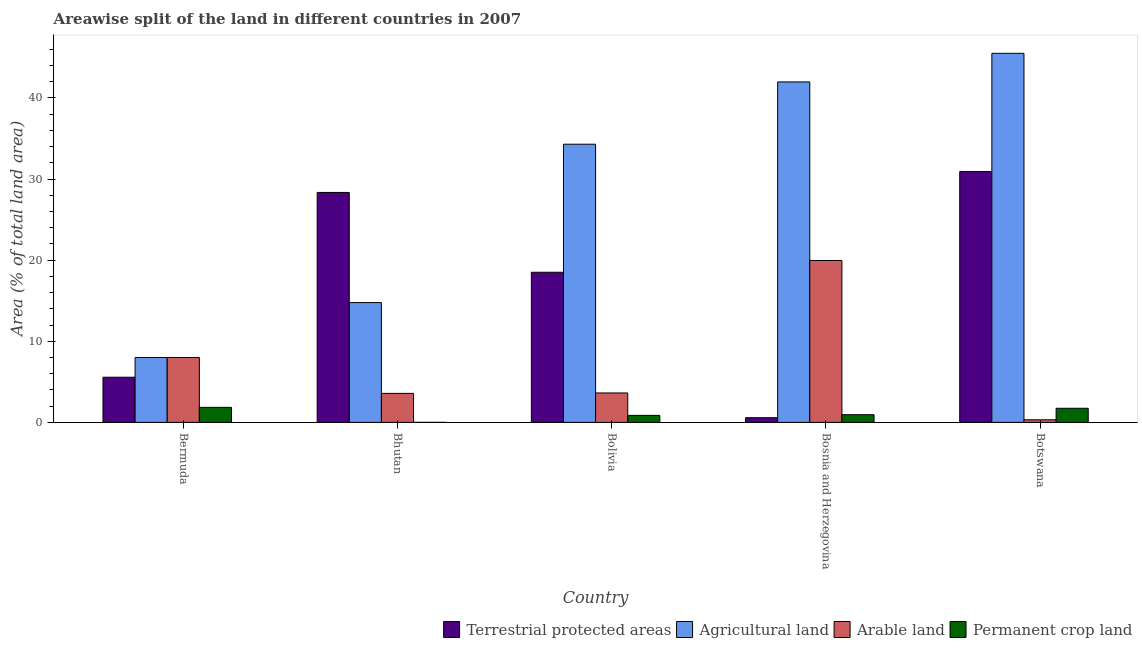Are the number of bars on each tick of the X-axis equal?
Your response must be concise. Yes. How many bars are there on the 4th tick from the right?
Give a very brief answer. 4. What is the label of the 5th group of bars from the left?
Provide a short and direct response. Botswana. In how many cases, is the number of bars for a given country not equal to the number of legend labels?
Your answer should be compact. 0. What is the percentage of area under arable land in Botswana?
Your answer should be very brief. 0.32. Across all countries, what is the maximum percentage of land under terrestrial protection?
Ensure brevity in your answer.  30.93. Across all countries, what is the minimum percentage of area under arable land?
Provide a succinct answer. 0.32. In which country was the percentage of area under agricultural land maximum?
Your answer should be very brief. Botswana. In which country was the percentage of area under permanent crop land minimum?
Offer a terse response. Bhutan. What is the total percentage of area under arable land in the graph?
Keep it short and to the point. 35.49. What is the difference between the percentage of area under arable land in Bermuda and that in Bolivia?
Offer a very short reply. 4.37. What is the difference between the percentage of area under permanent crop land in Bolivia and the percentage of area under arable land in Bhutan?
Give a very brief answer. -2.71. What is the average percentage of land under terrestrial protection per country?
Provide a succinct answer. 16.79. What is the difference between the percentage of land under terrestrial protection and percentage of area under agricultural land in Bosnia and Herzegovina?
Your answer should be very brief. -41.39. In how many countries, is the percentage of land under terrestrial protection greater than 42 %?
Your response must be concise. 0. What is the ratio of the percentage of area under permanent crop land in Bolivia to that in Botswana?
Ensure brevity in your answer.  0.5. Is the difference between the percentage of area under permanent crop land in Bosnia and Herzegovina and Botswana greater than the difference between the percentage of area under agricultural land in Bosnia and Herzegovina and Botswana?
Offer a very short reply. Yes. What is the difference between the highest and the second highest percentage of area under permanent crop land?
Offer a terse response. 0.12. What is the difference between the highest and the lowest percentage of land under terrestrial protection?
Offer a terse response. 30.35. Is the sum of the percentage of area under permanent crop land in Bermuda and Bhutan greater than the maximum percentage of land under terrestrial protection across all countries?
Provide a succinct answer. No. Is it the case that in every country, the sum of the percentage of area under permanent crop land and percentage of area under agricultural land is greater than the sum of percentage of land under terrestrial protection and percentage of area under arable land?
Ensure brevity in your answer.  No. What does the 2nd bar from the left in Bhutan represents?
Give a very brief answer. Agricultural land. What does the 4th bar from the right in Bolivia represents?
Your answer should be very brief. Terrestrial protected areas. Are all the bars in the graph horizontal?
Provide a succinct answer. No. What is the difference between two consecutive major ticks on the Y-axis?
Your response must be concise. 10. Are the values on the major ticks of Y-axis written in scientific E-notation?
Your response must be concise. No. How are the legend labels stacked?
Make the answer very short. Horizontal. What is the title of the graph?
Ensure brevity in your answer.  Areawise split of the land in different countries in 2007. Does "Taxes on revenue" appear as one of the legend labels in the graph?
Keep it short and to the point. No. What is the label or title of the X-axis?
Keep it short and to the point. Country. What is the label or title of the Y-axis?
Offer a very short reply. Area (% of total land area). What is the Area (% of total land area) in Terrestrial protected areas in Bermuda?
Offer a terse response. 5.57. What is the Area (% of total land area) of Arable land in Bermuda?
Offer a terse response. 8. What is the Area (% of total land area) of Permanent crop land in Bermuda?
Offer a terse response. 1.86. What is the Area (% of total land area) of Terrestrial protected areas in Bhutan?
Provide a succinct answer. 28.35. What is the Area (% of total land area) of Agricultural land in Bhutan?
Give a very brief answer. 14.77. What is the Area (% of total land area) in Arable land in Bhutan?
Make the answer very short. 3.58. What is the Area (% of total land area) in Permanent crop land in Bhutan?
Offer a very short reply. 0. What is the Area (% of total land area) in Terrestrial protected areas in Bolivia?
Your response must be concise. 18.51. What is the Area (% of total land area) in Agricultural land in Bolivia?
Offer a very short reply. 34.29. What is the Area (% of total land area) of Arable land in Bolivia?
Provide a short and direct response. 3.63. What is the Area (% of total land area) in Permanent crop land in Bolivia?
Provide a succinct answer. 0.87. What is the Area (% of total land area) in Terrestrial protected areas in Bosnia and Herzegovina?
Offer a very short reply. 0.58. What is the Area (% of total land area) of Agricultural land in Bosnia and Herzegovina?
Offer a very short reply. 41.97. What is the Area (% of total land area) of Arable land in Bosnia and Herzegovina?
Provide a short and direct response. 19.96. What is the Area (% of total land area) in Permanent crop land in Bosnia and Herzegovina?
Ensure brevity in your answer.  0.95. What is the Area (% of total land area) in Terrestrial protected areas in Botswana?
Give a very brief answer. 30.93. What is the Area (% of total land area) of Agricultural land in Botswana?
Ensure brevity in your answer.  45.5. What is the Area (% of total land area) of Arable land in Botswana?
Provide a short and direct response. 0.32. What is the Area (% of total land area) of Permanent crop land in Botswana?
Offer a very short reply. 1.74. Across all countries, what is the maximum Area (% of total land area) of Terrestrial protected areas?
Give a very brief answer. 30.93. Across all countries, what is the maximum Area (% of total land area) in Agricultural land?
Your response must be concise. 45.5. Across all countries, what is the maximum Area (% of total land area) in Arable land?
Ensure brevity in your answer.  19.96. Across all countries, what is the maximum Area (% of total land area) in Permanent crop land?
Your answer should be very brief. 1.86. Across all countries, what is the minimum Area (% of total land area) in Terrestrial protected areas?
Offer a very short reply. 0.58. Across all countries, what is the minimum Area (% of total land area) in Agricultural land?
Give a very brief answer. 8. Across all countries, what is the minimum Area (% of total land area) in Arable land?
Your response must be concise. 0.32. Across all countries, what is the minimum Area (% of total land area) in Permanent crop land?
Provide a short and direct response. 0. What is the total Area (% of total land area) in Terrestrial protected areas in the graph?
Provide a short and direct response. 83.94. What is the total Area (% of total land area) in Agricultural land in the graph?
Ensure brevity in your answer.  144.53. What is the total Area (% of total land area) of Arable land in the graph?
Keep it short and to the point. 35.49. What is the total Area (% of total land area) in Permanent crop land in the graph?
Your response must be concise. 5.42. What is the difference between the Area (% of total land area) of Terrestrial protected areas in Bermuda and that in Bhutan?
Your answer should be very brief. -22.78. What is the difference between the Area (% of total land area) in Agricultural land in Bermuda and that in Bhutan?
Keep it short and to the point. -6.77. What is the difference between the Area (% of total land area) in Arable land in Bermuda and that in Bhutan?
Give a very brief answer. 4.42. What is the difference between the Area (% of total land area) of Permanent crop land in Bermuda and that in Bhutan?
Offer a terse response. 1.85. What is the difference between the Area (% of total land area) in Terrestrial protected areas in Bermuda and that in Bolivia?
Your answer should be very brief. -12.94. What is the difference between the Area (% of total land area) of Agricultural land in Bermuda and that in Bolivia?
Your response must be concise. -26.29. What is the difference between the Area (% of total land area) of Arable land in Bermuda and that in Bolivia?
Ensure brevity in your answer.  4.37. What is the difference between the Area (% of total land area) in Terrestrial protected areas in Bermuda and that in Bosnia and Herzegovina?
Provide a short and direct response. 4.99. What is the difference between the Area (% of total land area) in Agricultural land in Bermuda and that in Bosnia and Herzegovina?
Keep it short and to the point. -33.97. What is the difference between the Area (% of total land area) in Arable land in Bermuda and that in Bosnia and Herzegovina?
Give a very brief answer. -11.96. What is the difference between the Area (% of total land area) of Permanent crop land in Bermuda and that in Bosnia and Herzegovina?
Your answer should be compact. 0.91. What is the difference between the Area (% of total land area) in Terrestrial protected areas in Bermuda and that in Botswana?
Provide a succinct answer. -25.36. What is the difference between the Area (% of total land area) of Agricultural land in Bermuda and that in Botswana?
Ensure brevity in your answer.  -37.5. What is the difference between the Area (% of total land area) of Arable land in Bermuda and that in Botswana?
Your response must be concise. 7.68. What is the difference between the Area (% of total land area) in Permanent crop land in Bermuda and that in Botswana?
Ensure brevity in your answer.  0.12. What is the difference between the Area (% of total land area) in Terrestrial protected areas in Bhutan and that in Bolivia?
Your answer should be compact. 9.84. What is the difference between the Area (% of total land area) of Agricultural land in Bhutan and that in Bolivia?
Offer a terse response. -19.52. What is the difference between the Area (% of total land area) in Arable land in Bhutan and that in Bolivia?
Offer a very short reply. -0.05. What is the difference between the Area (% of total land area) in Permanent crop land in Bhutan and that in Bolivia?
Offer a terse response. -0.86. What is the difference between the Area (% of total land area) in Terrestrial protected areas in Bhutan and that in Bosnia and Herzegovina?
Offer a very short reply. 27.77. What is the difference between the Area (% of total land area) of Agricultural land in Bhutan and that in Bosnia and Herzegovina?
Provide a short and direct response. -27.2. What is the difference between the Area (% of total land area) of Arable land in Bhutan and that in Bosnia and Herzegovina?
Your answer should be very brief. -16.39. What is the difference between the Area (% of total land area) in Permanent crop land in Bhutan and that in Bosnia and Herzegovina?
Provide a succinct answer. -0.95. What is the difference between the Area (% of total land area) of Terrestrial protected areas in Bhutan and that in Botswana?
Ensure brevity in your answer.  -2.59. What is the difference between the Area (% of total land area) in Agricultural land in Bhutan and that in Botswana?
Your response must be concise. -30.73. What is the difference between the Area (% of total land area) in Arable land in Bhutan and that in Botswana?
Offer a very short reply. 3.25. What is the difference between the Area (% of total land area) in Permanent crop land in Bhutan and that in Botswana?
Give a very brief answer. -1.74. What is the difference between the Area (% of total land area) of Terrestrial protected areas in Bolivia and that in Bosnia and Herzegovina?
Offer a terse response. 17.93. What is the difference between the Area (% of total land area) in Agricultural land in Bolivia and that in Bosnia and Herzegovina?
Make the answer very short. -7.68. What is the difference between the Area (% of total land area) of Arable land in Bolivia and that in Bosnia and Herzegovina?
Offer a very short reply. -16.33. What is the difference between the Area (% of total land area) in Permanent crop land in Bolivia and that in Bosnia and Herzegovina?
Offer a terse response. -0.08. What is the difference between the Area (% of total land area) of Terrestrial protected areas in Bolivia and that in Botswana?
Your response must be concise. -12.43. What is the difference between the Area (% of total land area) in Agricultural land in Bolivia and that in Botswana?
Give a very brief answer. -11.2. What is the difference between the Area (% of total land area) in Arable land in Bolivia and that in Botswana?
Ensure brevity in your answer.  3.31. What is the difference between the Area (% of total land area) of Permanent crop land in Bolivia and that in Botswana?
Your response must be concise. -0.87. What is the difference between the Area (% of total land area) of Terrestrial protected areas in Bosnia and Herzegovina and that in Botswana?
Make the answer very short. -30.35. What is the difference between the Area (% of total land area) of Agricultural land in Bosnia and Herzegovina and that in Botswana?
Your response must be concise. -3.52. What is the difference between the Area (% of total land area) of Arable land in Bosnia and Herzegovina and that in Botswana?
Give a very brief answer. 19.64. What is the difference between the Area (% of total land area) in Permanent crop land in Bosnia and Herzegovina and that in Botswana?
Your answer should be very brief. -0.79. What is the difference between the Area (% of total land area) in Terrestrial protected areas in Bermuda and the Area (% of total land area) in Agricultural land in Bhutan?
Offer a terse response. -9.2. What is the difference between the Area (% of total land area) in Terrestrial protected areas in Bermuda and the Area (% of total land area) in Arable land in Bhutan?
Provide a short and direct response. 1.99. What is the difference between the Area (% of total land area) of Terrestrial protected areas in Bermuda and the Area (% of total land area) of Permanent crop land in Bhutan?
Your answer should be compact. 5.57. What is the difference between the Area (% of total land area) of Agricultural land in Bermuda and the Area (% of total land area) of Arable land in Bhutan?
Provide a succinct answer. 4.42. What is the difference between the Area (% of total land area) in Agricultural land in Bermuda and the Area (% of total land area) in Permanent crop land in Bhutan?
Give a very brief answer. 8. What is the difference between the Area (% of total land area) in Arable land in Bermuda and the Area (% of total land area) in Permanent crop land in Bhutan?
Your answer should be very brief. 8. What is the difference between the Area (% of total land area) of Terrestrial protected areas in Bermuda and the Area (% of total land area) of Agricultural land in Bolivia?
Your answer should be compact. -28.72. What is the difference between the Area (% of total land area) of Terrestrial protected areas in Bermuda and the Area (% of total land area) of Arable land in Bolivia?
Your answer should be very brief. 1.94. What is the difference between the Area (% of total land area) in Terrestrial protected areas in Bermuda and the Area (% of total land area) in Permanent crop land in Bolivia?
Give a very brief answer. 4.7. What is the difference between the Area (% of total land area) in Agricultural land in Bermuda and the Area (% of total land area) in Arable land in Bolivia?
Your answer should be very brief. 4.37. What is the difference between the Area (% of total land area) of Agricultural land in Bermuda and the Area (% of total land area) of Permanent crop land in Bolivia?
Your answer should be very brief. 7.13. What is the difference between the Area (% of total land area) of Arable land in Bermuda and the Area (% of total land area) of Permanent crop land in Bolivia?
Your answer should be very brief. 7.13. What is the difference between the Area (% of total land area) in Terrestrial protected areas in Bermuda and the Area (% of total land area) in Agricultural land in Bosnia and Herzegovina?
Make the answer very short. -36.4. What is the difference between the Area (% of total land area) of Terrestrial protected areas in Bermuda and the Area (% of total land area) of Arable land in Bosnia and Herzegovina?
Your answer should be compact. -14.39. What is the difference between the Area (% of total land area) in Terrestrial protected areas in Bermuda and the Area (% of total land area) in Permanent crop land in Bosnia and Herzegovina?
Ensure brevity in your answer.  4.62. What is the difference between the Area (% of total land area) of Agricultural land in Bermuda and the Area (% of total land area) of Arable land in Bosnia and Herzegovina?
Your answer should be very brief. -11.96. What is the difference between the Area (% of total land area) of Agricultural land in Bermuda and the Area (% of total land area) of Permanent crop land in Bosnia and Herzegovina?
Make the answer very short. 7.05. What is the difference between the Area (% of total land area) in Arable land in Bermuda and the Area (% of total land area) in Permanent crop land in Bosnia and Herzegovina?
Give a very brief answer. 7.05. What is the difference between the Area (% of total land area) in Terrestrial protected areas in Bermuda and the Area (% of total land area) in Agricultural land in Botswana?
Offer a very short reply. -39.93. What is the difference between the Area (% of total land area) of Terrestrial protected areas in Bermuda and the Area (% of total land area) of Arable land in Botswana?
Ensure brevity in your answer.  5.25. What is the difference between the Area (% of total land area) in Terrestrial protected areas in Bermuda and the Area (% of total land area) in Permanent crop land in Botswana?
Provide a succinct answer. 3.83. What is the difference between the Area (% of total land area) of Agricultural land in Bermuda and the Area (% of total land area) of Arable land in Botswana?
Ensure brevity in your answer.  7.68. What is the difference between the Area (% of total land area) of Agricultural land in Bermuda and the Area (% of total land area) of Permanent crop land in Botswana?
Offer a very short reply. 6.26. What is the difference between the Area (% of total land area) in Arable land in Bermuda and the Area (% of total land area) in Permanent crop land in Botswana?
Make the answer very short. 6.26. What is the difference between the Area (% of total land area) in Terrestrial protected areas in Bhutan and the Area (% of total land area) in Agricultural land in Bolivia?
Your answer should be very brief. -5.95. What is the difference between the Area (% of total land area) in Terrestrial protected areas in Bhutan and the Area (% of total land area) in Arable land in Bolivia?
Offer a very short reply. 24.72. What is the difference between the Area (% of total land area) of Terrestrial protected areas in Bhutan and the Area (% of total land area) of Permanent crop land in Bolivia?
Your response must be concise. 27.48. What is the difference between the Area (% of total land area) in Agricultural land in Bhutan and the Area (% of total land area) in Arable land in Bolivia?
Ensure brevity in your answer.  11.14. What is the difference between the Area (% of total land area) of Agricultural land in Bhutan and the Area (% of total land area) of Permanent crop land in Bolivia?
Provide a succinct answer. 13.9. What is the difference between the Area (% of total land area) of Arable land in Bhutan and the Area (% of total land area) of Permanent crop land in Bolivia?
Offer a very short reply. 2.71. What is the difference between the Area (% of total land area) in Terrestrial protected areas in Bhutan and the Area (% of total land area) in Agricultural land in Bosnia and Herzegovina?
Provide a succinct answer. -13.63. What is the difference between the Area (% of total land area) in Terrestrial protected areas in Bhutan and the Area (% of total land area) in Arable land in Bosnia and Herzegovina?
Your answer should be compact. 8.39. What is the difference between the Area (% of total land area) in Terrestrial protected areas in Bhutan and the Area (% of total land area) in Permanent crop land in Bosnia and Herzegovina?
Ensure brevity in your answer.  27.4. What is the difference between the Area (% of total land area) in Agricultural land in Bhutan and the Area (% of total land area) in Arable land in Bosnia and Herzegovina?
Provide a succinct answer. -5.19. What is the difference between the Area (% of total land area) in Agricultural land in Bhutan and the Area (% of total land area) in Permanent crop land in Bosnia and Herzegovina?
Offer a very short reply. 13.82. What is the difference between the Area (% of total land area) in Arable land in Bhutan and the Area (% of total land area) in Permanent crop land in Bosnia and Herzegovina?
Offer a terse response. 2.63. What is the difference between the Area (% of total land area) of Terrestrial protected areas in Bhutan and the Area (% of total land area) of Agricultural land in Botswana?
Provide a succinct answer. -17.15. What is the difference between the Area (% of total land area) in Terrestrial protected areas in Bhutan and the Area (% of total land area) in Arable land in Botswana?
Provide a succinct answer. 28.03. What is the difference between the Area (% of total land area) in Terrestrial protected areas in Bhutan and the Area (% of total land area) in Permanent crop land in Botswana?
Keep it short and to the point. 26.61. What is the difference between the Area (% of total land area) in Agricultural land in Bhutan and the Area (% of total land area) in Arable land in Botswana?
Keep it short and to the point. 14.45. What is the difference between the Area (% of total land area) of Agricultural land in Bhutan and the Area (% of total land area) of Permanent crop land in Botswana?
Offer a terse response. 13.03. What is the difference between the Area (% of total land area) in Arable land in Bhutan and the Area (% of total land area) in Permanent crop land in Botswana?
Your response must be concise. 1.84. What is the difference between the Area (% of total land area) of Terrestrial protected areas in Bolivia and the Area (% of total land area) of Agricultural land in Bosnia and Herzegovina?
Your response must be concise. -23.47. What is the difference between the Area (% of total land area) of Terrestrial protected areas in Bolivia and the Area (% of total land area) of Arable land in Bosnia and Herzegovina?
Offer a terse response. -1.45. What is the difference between the Area (% of total land area) in Terrestrial protected areas in Bolivia and the Area (% of total land area) in Permanent crop land in Bosnia and Herzegovina?
Give a very brief answer. 17.56. What is the difference between the Area (% of total land area) of Agricultural land in Bolivia and the Area (% of total land area) of Arable land in Bosnia and Herzegovina?
Offer a very short reply. 14.33. What is the difference between the Area (% of total land area) in Agricultural land in Bolivia and the Area (% of total land area) in Permanent crop land in Bosnia and Herzegovina?
Your response must be concise. 33.34. What is the difference between the Area (% of total land area) of Arable land in Bolivia and the Area (% of total land area) of Permanent crop land in Bosnia and Herzegovina?
Give a very brief answer. 2.68. What is the difference between the Area (% of total land area) in Terrestrial protected areas in Bolivia and the Area (% of total land area) in Agricultural land in Botswana?
Give a very brief answer. -26.99. What is the difference between the Area (% of total land area) in Terrestrial protected areas in Bolivia and the Area (% of total land area) in Arable land in Botswana?
Offer a terse response. 18.19. What is the difference between the Area (% of total land area) of Terrestrial protected areas in Bolivia and the Area (% of total land area) of Permanent crop land in Botswana?
Keep it short and to the point. 16.77. What is the difference between the Area (% of total land area) of Agricultural land in Bolivia and the Area (% of total land area) of Arable land in Botswana?
Keep it short and to the point. 33.97. What is the difference between the Area (% of total land area) of Agricultural land in Bolivia and the Area (% of total land area) of Permanent crop land in Botswana?
Provide a succinct answer. 32.55. What is the difference between the Area (% of total land area) of Arable land in Bolivia and the Area (% of total land area) of Permanent crop land in Botswana?
Your answer should be very brief. 1.89. What is the difference between the Area (% of total land area) in Terrestrial protected areas in Bosnia and Herzegovina and the Area (% of total land area) in Agricultural land in Botswana?
Give a very brief answer. -44.92. What is the difference between the Area (% of total land area) in Terrestrial protected areas in Bosnia and Herzegovina and the Area (% of total land area) in Arable land in Botswana?
Offer a terse response. 0.26. What is the difference between the Area (% of total land area) in Terrestrial protected areas in Bosnia and Herzegovina and the Area (% of total land area) in Permanent crop land in Botswana?
Your answer should be very brief. -1.16. What is the difference between the Area (% of total land area) in Agricultural land in Bosnia and Herzegovina and the Area (% of total land area) in Arable land in Botswana?
Offer a very short reply. 41.65. What is the difference between the Area (% of total land area) of Agricultural land in Bosnia and Herzegovina and the Area (% of total land area) of Permanent crop land in Botswana?
Make the answer very short. 40.23. What is the difference between the Area (% of total land area) in Arable land in Bosnia and Herzegovina and the Area (% of total land area) in Permanent crop land in Botswana?
Your response must be concise. 18.22. What is the average Area (% of total land area) of Terrestrial protected areas per country?
Your answer should be compact. 16.79. What is the average Area (% of total land area) in Agricultural land per country?
Provide a short and direct response. 28.91. What is the average Area (% of total land area) of Arable land per country?
Make the answer very short. 7.1. What is the average Area (% of total land area) in Permanent crop land per country?
Provide a short and direct response. 1.08. What is the difference between the Area (% of total land area) in Terrestrial protected areas and Area (% of total land area) in Agricultural land in Bermuda?
Your answer should be compact. -2.43. What is the difference between the Area (% of total land area) of Terrestrial protected areas and Area (% of total land area) of Arable land in Bermuda?
Your response must be concise. -2.43. What is the difference between the Area (% of total land area) of Terrestrial protected areas and Area (% of total land area) of Permanent crop land in Bermuda?
Offer a terse response. 3.71. What is the difference between the Area (% of total land area) in Agricultural land and Area (% of total land area) in Arable land in Bermuda?
Provide a succinct answer. 0. What is the difference between the Area (% of total land area) of Agricultural land and Area (% of total land area) of Permanent crop land in Bermuda?
Keep it short and to the point. 6.14. What is the difference between the Area (% of total land area) of Arable land and Area (% of total land area) of Permanent crop land in Bermuda?
Make the answer very short. 6.14. What is the difference between the Area (% of total land area) in Terrestrial protected areas and Area (% of total land area) in Agricultural land in Bhutan?
Make the answer very short. 13.58. What is the difference between the Area (% of total land area) of Terrestrial protected areas and Area (% of total land area) of Arable land in Bhutan?
Provide a short and direct response. 24.77. What is the difference between the Area (% of total land area) of Terrestrial protected areas and Area (% of total land area) of Permanent crop land in Bhutan?
Your response must be concise. 28.34. What is the difference between the Area (% of total land area) of Agricultural land and Area (% of total land area) of Arable land in Bhutan?
Your response must be concise. 11.19. What is the difference between the Area (% of total land area) in Agricultural land and Area (% of total land area) in Permanent crop land in Bhutan?
Offer a terse response. 14.77. What is the difference between the Area (% of total land area) of Arable land and Area (% of total land area) of Permanent crop land in Bhutan?
Offer a terse response. 3.57. What is the difference between the Area (% of total land area) of Terrestrial protected areas and Area (% of total land area) of Agricultural land in Bolivia?
Provide a short and direct response. -15.79. What is the difference between the Area (% of total land area) of Terrestrial protected areas and Area (% of total land area) of Arable land in Bolivia?
Give a very brief answer. 14.88. What is the difference between the Area (% of total land area) in Terrestrial protected areas and Area (% of total land area) in Permanent crop land in Bolivia?
Give a very brief answer. 17.64. What is the difference between the Area (% of total land area) of Agricultural land and Area (% of total land area) of Arable land in Bolivia?
Ensure brevity in your answer.  30.66. What is the difference between the Area (% of total land area) of Agricultural land and Area (% of total land area) of Permanent crop land in Bolivia?
Keep it short and to the point. 33.43. What is the difference between the Area (% of total land area) in Arable land and Area (% of total land area) in Permanent crop land in Bolivia?
Your answer should be compact. 2.76. What is the difference between the Area (% of total land area) of Terrestrial protected areas and Area (% of total land area) of Agricultural land in Bosnia and Herzegovina?
Your response must be concise. -41.39. What is the difference between the Area (% of total land area) in Terrestrial protected areas and Area (% of total land area) in Arable land in Bosnia and Herzegovina?
Provide a succinct answer. -19.38. What is the difference between the Area (% of total land area) in Terrestrial protected areas and Area (% of total land area) in Permanent crop land in Bosnia and Herzegovina?
Your response must be concise. -0.37. What is the difference between the Area (% of total land area) of Agricultural land and Area (% of total land area) of Arable land in Bosnia and Herzegovina?
Give a very brief answer. 22.01. What is the difference between the Area (% of total land area) in Agricultural land and Area (% of total land area) in Permanent crop land in Bosnia and Herzegovina?
Provide a succinct answer. 41.02. What is the difference between the Area (% of total land area) in Arable land and Area (% of total land area) in Permanent crop land in Bosnia and Herzegovina?
Your answer should be compact. 19.01. What is the difference between the Area (% of total land area) of Terrestrial protected areas and Area (% of total land area) of Agricultural land in Botswana?
Keep it short and to the point. -14.56. What is the difference between the Area (% of total land area) of Terrestrial protected areas and Area (% of total land area) of Arable land in Botswana?
Make the answer very short. 30.61. What is the difference between the Area (% of total land area) of Terrestrial protected areas and Area (% of total land area) of Permanent crop land in Botswana?
Give a very brief answer. 29.19. What is the difference between the Area (% of total land area) in Agricultural land and Area (% of total land area) in Arable land in Botswana?
Provide a short and direct response. 45.17. What is the difference between the Area (% of total land area) in Agricultural land and Area (% of total land area) in Permanent crop land in Botswana?
Offer a very short reply. 43.76. What is the difference between the Area (% of total land area) in Arable land and Area (% of total land area) in Permanent crop land in Botswana?
Your response must be concise. -1.42. What is the ratio of the Area (% of total land area) in Terrestrial protected areas in Bermuda to that in Bhutan?
Offer a very short reply. 0.2. What is the ratio of the Area (% of total land area) in Agricultural land in Bermuda to that in Bhutan?
Give a very brief answer. 0.54. What is the ratio of the Area (% of total land area) of Arable land in Bermuda to that in Bhutan?
Keep it short and to the point. 2.24. What is the ratio of the Area (% of total land area) of Permanent crop land in Bermuda to that in Bhutan?
Make the answer very short. 525.77. What is the ratio of the Area (% of total land area) of Terrestrial protected areas in Bermuda to that in Bolivia?
Give a very brief answer. 0.3. What is the ratio of the Area (% of total land area) of Agricultural land in Bermuda to that in Bolivia?
Your answer should be very brief. 0.23. What is the ratio of the Area (% of total land area) in Arable land in Bermuda to that in Bolivia?
Your response must be concise. 2.2. What is the ratio of the Area (% of total land area) in Permanent crop land in Bermuda to that in Bolivia?
Offer a terse response. 2.14. What is the ratio of the Area (% of total land area) of Terrestrial protected areas in Bermuda to that in Bosnia and Herzegovina?
Make the answer very short. 9.6. What is the ratio of the Area (% of total land area) in Agricultural land in Bermuda to that in Bosnia and Herzegovina?
Your response must be concise. 0.19. What is the ratio of the Area (% of total land area) in Arable land in Bermuda to that in Bosnia and Herzegovina?
Provide a succinct answer. 0.4. What is the ratio of the Area (% of total land area) in Permanent crop land in Bermuda to that in Bosnia and Herzegovina?
Your answer should be very brief. 1.96. What is the ratio of the Area (% of total land area) of Terrestrial protected areas in Bermuda to that in Botswana?
Ensure brevity in your answer.  0.18. What is the ratio of the Area (% of total land area) of Agricultural land in Bermuda to that in Botswana?
Your response must be concise. 0.18. What is the ratio of the Area (% of total land area) in Arable land in Bermuda to that in Botswana?
Ensure brevity in your answer.  24.91. What is the ratio of the Area (% of total land area) in Permanent crop land in Bermuda to that in Botswana?
Your response must be concise. 1.07. What is the ratio of the Area (% of total land area) of Terrestrial protected areas in Bhutan to that in Bolivia?
Your answer should be very brief. 1.53. What is the ratio of the Area (% of total land area) of Agricultural land in Bhutan to that in Bolivia?
Ensure brevity in your answer.  0.43. What is the ratio of the Area (% of total land area) of Arable land in Bhutan to that in Bolivia?
Offer a terse response. 0.99. What is the ratio of the Area (% of total land area) in Permanent crop land in Bhutan to that in Bolivia?
Keep it short and to the point. 0. What is the ratio of the Area (% of total land area) in Terrestrial protected areas in Bhutan to that in Bosnia and Herzegovina?
Provide a succinct answer. 48.88. What is the ratio of the Area (% of total land area) of Agricultural land in Bhutan to that in Bosnia and Herzegovina?
Your answer should be compact. 0.35. What is the ratio of the Area (% of total land area) of Arable land in Bhutan to that in Bosnia and Herzegovina?
Provide a succinct answer. 0.18. What is the ratio of the Area (% of total land area) of Permanent crop land in Bhutan to that in Bosnia and Herzegovina?
Keep it short and to the point. 0. What is the ratio of the Area (% of total land area) in Terrestrial protected areas in Bhutan to that in Botswana?
Your answer should be compact. 0.92. What is the ratio of the Area (% of total land area) in Agricultural land in Bhutan to that in Botswana?
Offer a terse response. 0.32. What is the ratio of the Area (% of total land area) of Arable land in Bhutan to that in Botswana?
Provide a short and direct response. 11.13. What is the ratio of the Area (% of total land area) of Permanent crop land in Bhutan to that in Botswana?
Ensure brevity in your answer.  0. What is the ratio of the Area (% of total land area) in Terrestrial protected areas in Bolivia to that in Bosnia and Herzegovina?
Offer a terse response. 31.91. What is the ratio of the Area (% of total land area) of Agricultural land in Bolivia to that in Bosnia and Herzegovina?
Ensure brevity in your answer.  0.82. What is the ratio of the Area (% of total land area) of Arable land in Bolivia to that in Bosnia and Herzegovina?
Your answer should be compact. 0.18. What is the ratio of the Area (% of total land area) of Permanent crop land in Bolivia to that in Bosnia and Herzegovina?
Keep it short and to the point. 0.91. What is the ratio of the Area (% of total land area) of Terrestrial protected areas in Bolivia to that in Botswana?
Provide a short and direct response. 0.6. What is the ratio of the Area (% of total land area) of Agricultural land in Bolivia to that in Botswana?
Offer a very short reply. 0.75. What is the ratio of the Area (% of total land area) of Arable land in Bolivia to that in Botswana?
Offer a terse response. 11.3. What is the ratio of the Area (% of total land area) of Permanent crop land in Bolivia to that in Botswana?
Provide a succinct answer. 0.5. What is the ratio of the Area (% of total land area) of Terrestrial protected areas in Bosnia and Herzegovina to that in Botswana?
Keep it short and to the point. 0.02. What is the ratio of the Area (% of total land area) in Agricultural land in Bosnia and Herzegovina to that in Botswana?
Your answer should be compact. 0.92. What is the ratio of the Area (% of total land area) of Arable land in Bosnia and Herzegovina to that in Botswana?
Your response must be concise. 62.16. What is the ratio of the Area (% of total land area) in Permanent crop land in Bosnia and Herzegovina to that in Botswana?
Make the answer very short. 0.55. What is the difference between the highest and the second highest Area (% of total land area) in Terrestrial protected areas?
Offer a terse response. 2.59. What is the difference between the highest and the second highest Area (% of total land area) in Agricultural land?
Make the answer very short. 3.52. What is the difference between the highest and the second highest Area (% of total land area) of Arable land?
Your answer should be very brief. 11.96. What is the difference between the highest and the second highest Area (% of total land area) of Permanent crop land?
Ensure brevity in your answer.  0.12. What is the difference between the highest and the lowest Area (% of total land area) in Terrestrial protected areas?
Provide a succinct answer. 30.35. What is the difference between the highest and the lowest Area (% of total land area) in Agricultural land?
Make the answer very short. 37.5. What is the difference between the highest and the lowest Area (% of total land area) in Arable land?
Offer a very short reply. 19.64. What is the difference between the highest and the lowest Area (% of total land area) in Permanent crop land?
Give a very brief answer. 1.85. 